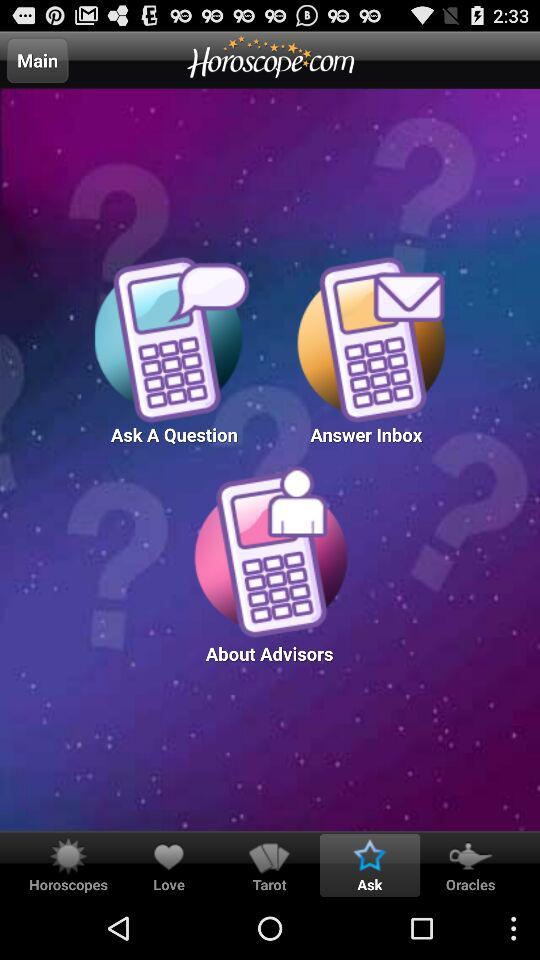How can we contact an advisor by phone?
When the provided information is insufficient, respond with <no answer>. <no answer> 